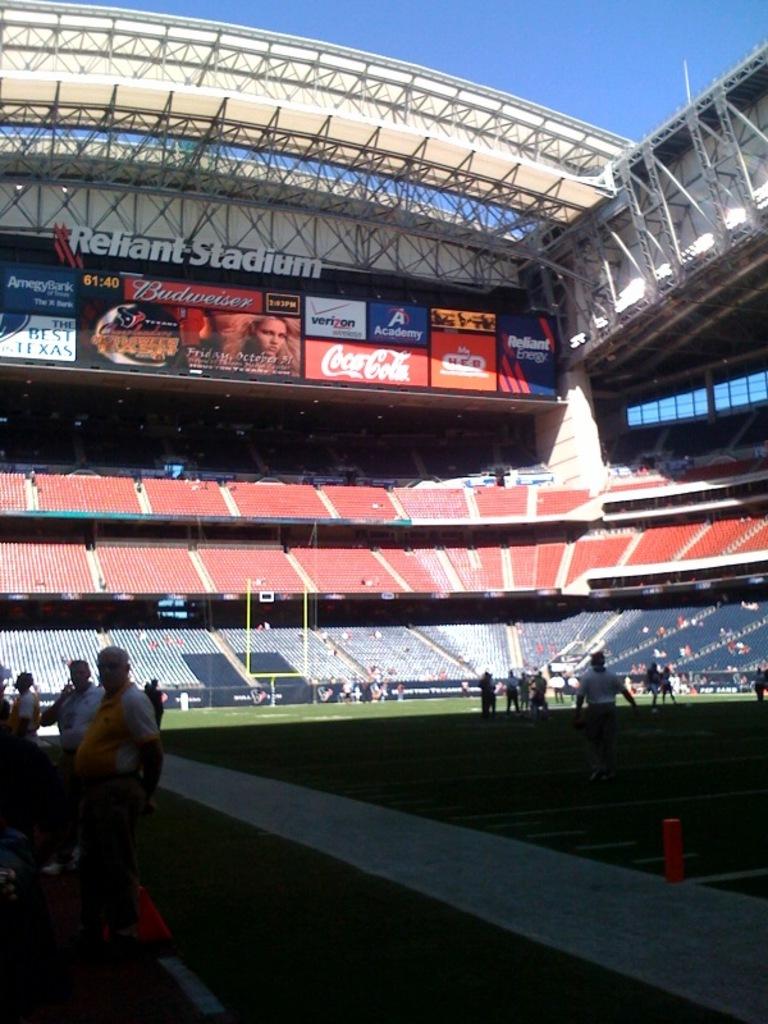What is the name of this stadium?
Keep it short and to the point. Reliant stadium. Is coke a cola a sponsor?
Ensure brevity in your answer.  Yes. 